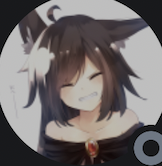what could this be?
 This is an anime-style drawing of a girl with cat ears. She has black hair and blue eyes, and is smiling. She is wearing a black dress with a white collar. 